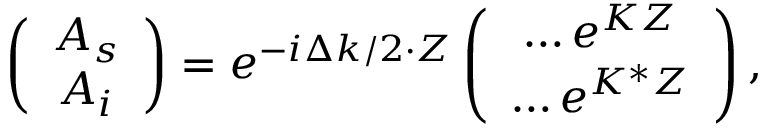<formula> <loc_0><loc_0><loc_500><loc_500>\begin{array} { r } { \left ( \begin{array} { c } { A _ { s } } \\ { A _ { i } } \end{array} \right ) = e ^ { - i \Delta k / 2 \cdot Z } \left ( \begin{array} { c } { \dots e ^ { K Z } } \\ { \dots e ^ { K ^ { * } Z } } \end{array} \right ) , } \end{array}</formula> 